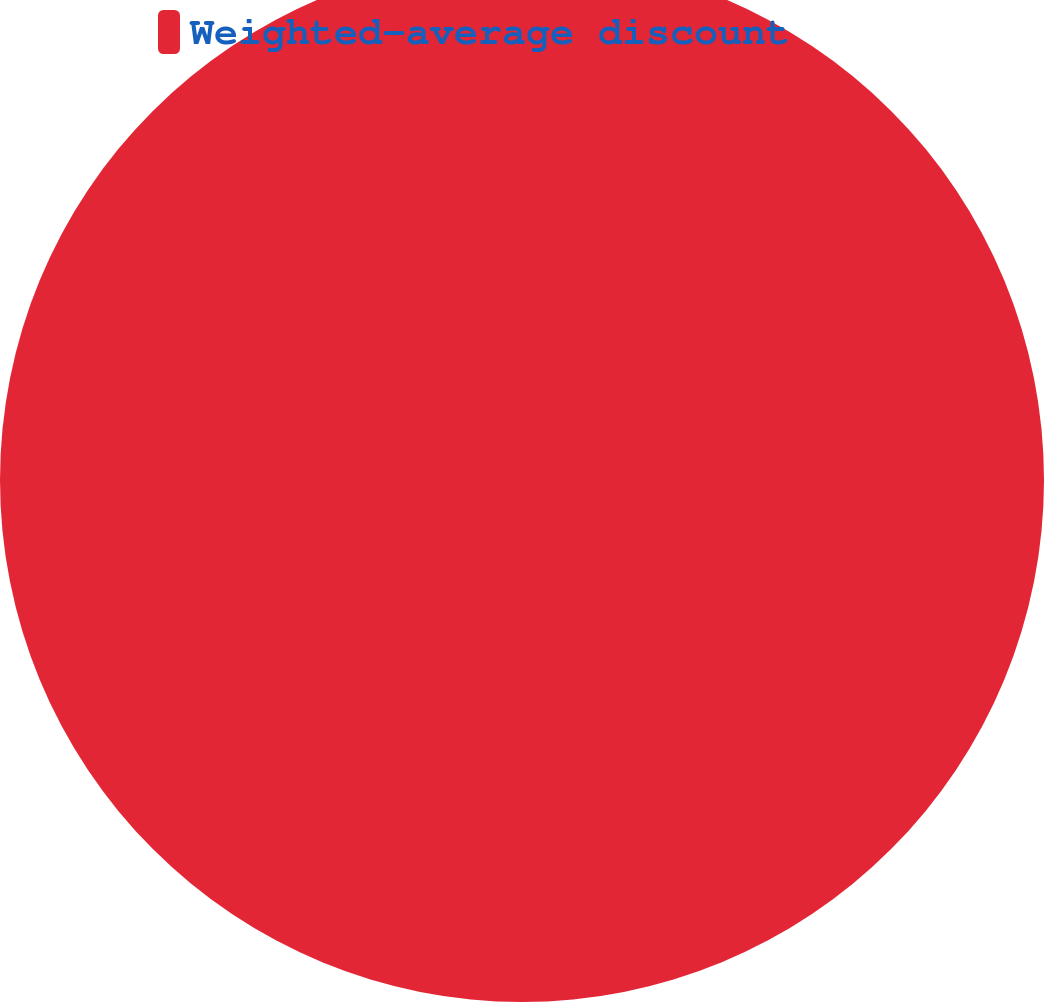Convert chart to OTSL. <chart><loc_0><loc_0><loc_500><loc_500><pie_chart><fcel>Weighted-average discount<nl><fcel>100.0%<nl></chart> 